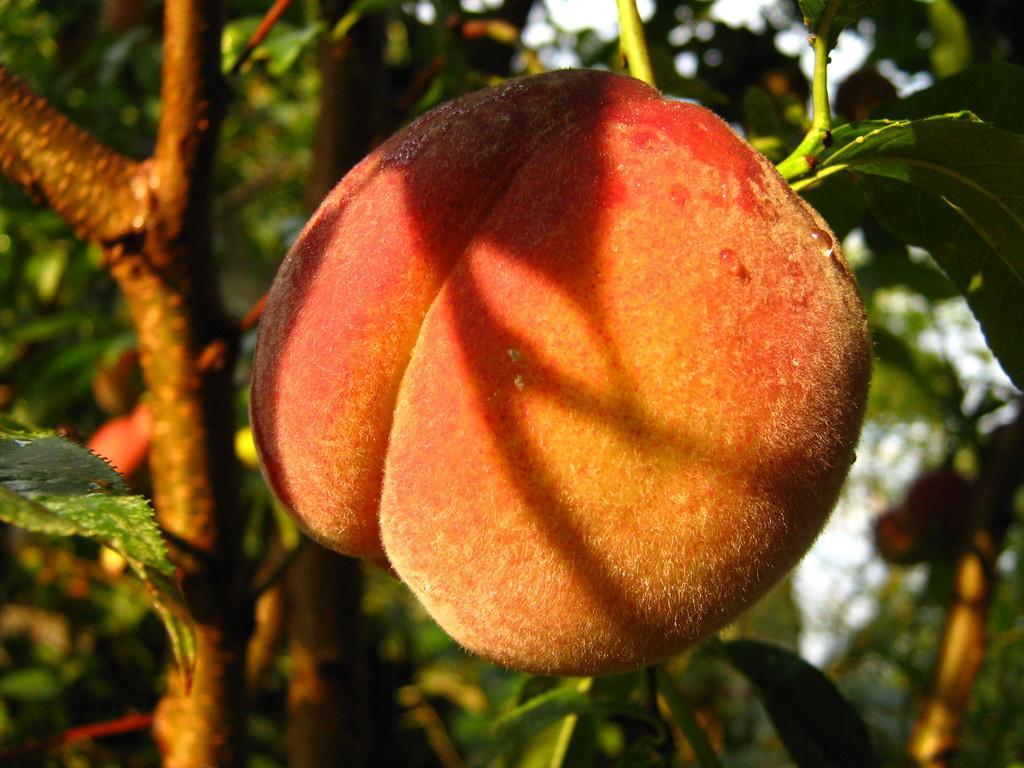Please provide a concise description of this image. In the center of the picture there is a fruit. In the background there are stems and leaves of the tree. It is sunny. The background is blurred. 